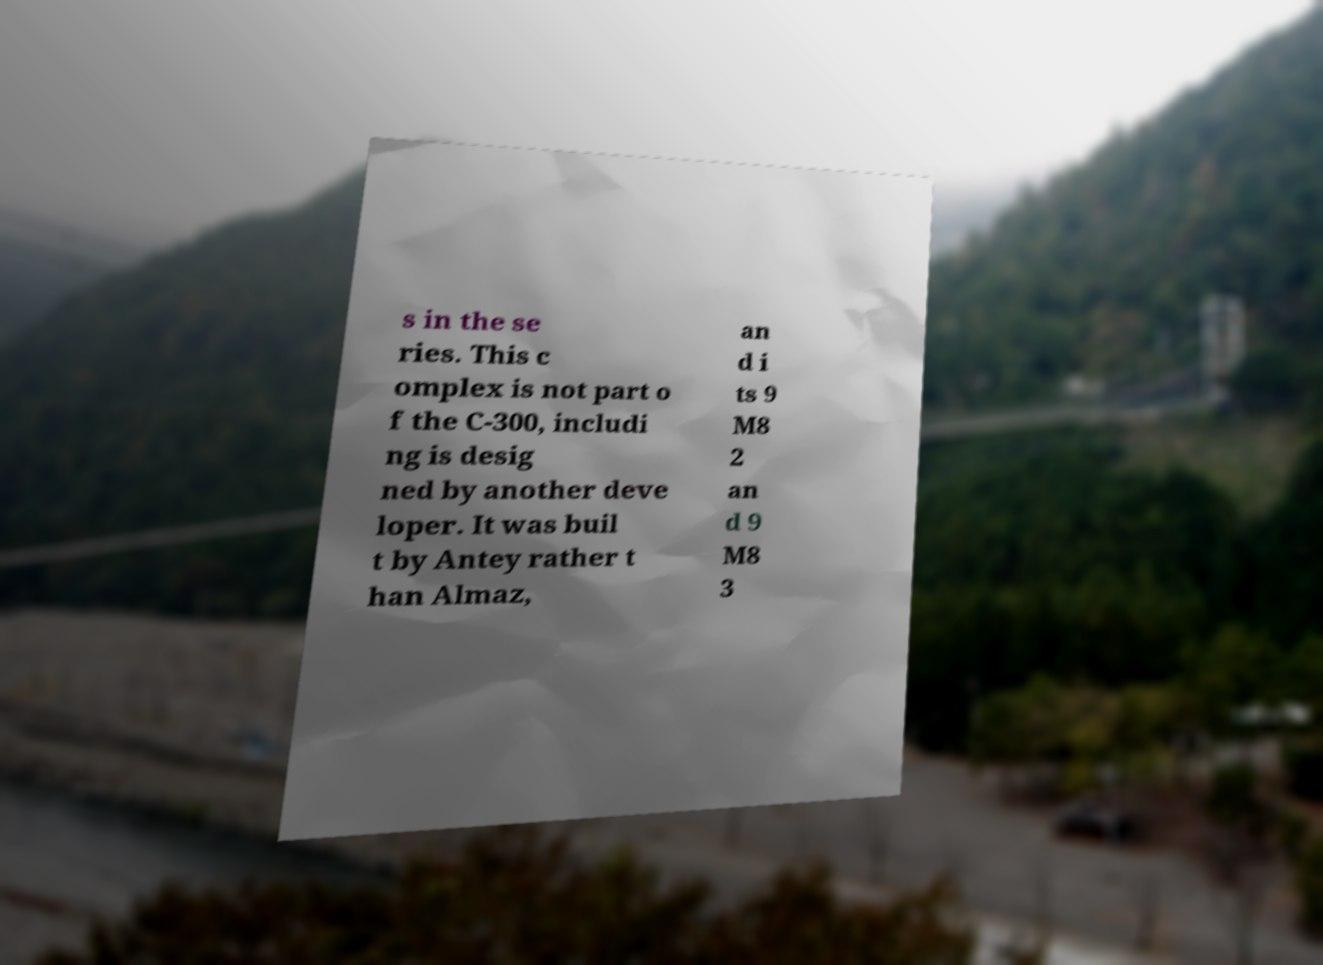Please identify and transcribe the text found in this image. s in the se ries. This c omplex is not part o f the C-300, includi ng is desig ned by another deve loper. It was buil t by Antey rather t han Almaz, an d i ts 9 M8 2 an d 9 M8 3 